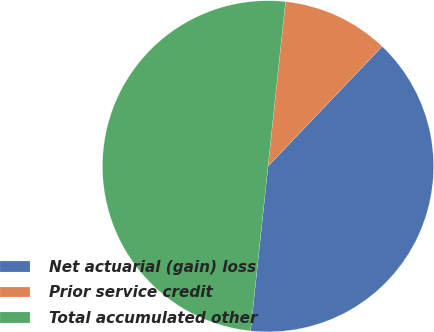<chart> <loc_0><loc_0><loc_500><loc_500><pie_chart><fcel>Net actuarial (gain) loss<fcel>Prior service credit<fcel>Total accumulated other<nl><fcel>39.58%<fcel>10.42%<fcel>50.0%<nl></chart> 